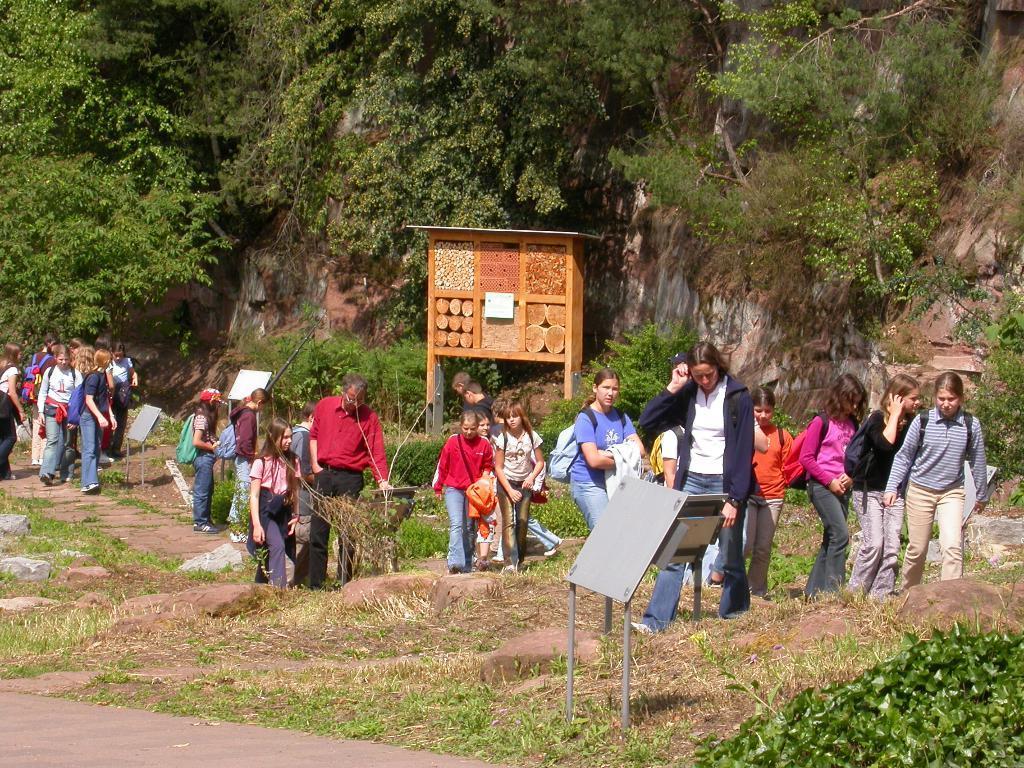Could you give a brief overview of what you see in this image? In this picture in the center there are persons walking. There is grass on the ground and there is a board which is grey in colour. In the background there are trees and there is a wooden stand. 